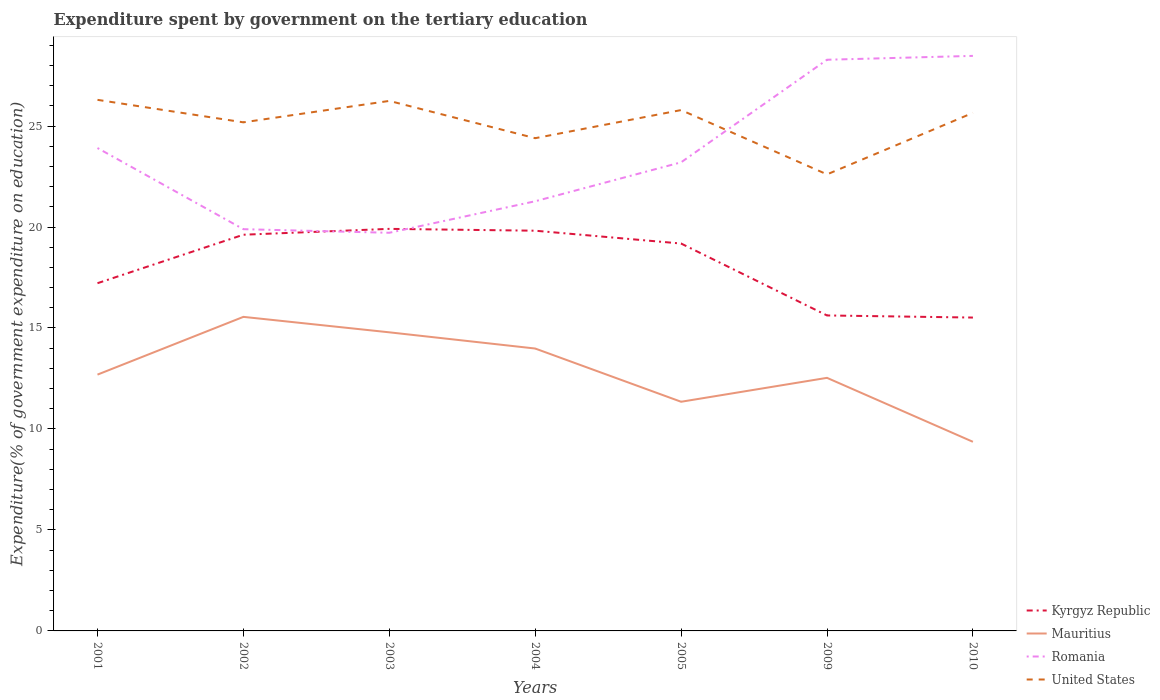Is the number of lines equal to the number of legend labels?
Your response must be concise. Yes. Across all years, what is the maximum expenditure spent by government on the tertiary education in United States?
Your answer should be compact. 22.61. In which year was the expenditure spent by government on the tertiary education in Romania maximum?
Your response must be concise. 2003. What is the total expenditure spent by government on the tertiary education in Kyrgyz Republic in the graph?
Provide a short and direct response. 0.44. What is the difference between the highest and the second highest expenditure spent by government on the tertiary education in Kyrgyz Republic?
Your answer should be compact. 4.39. What is the difference between the highest and the lowest expenditure spent by government on the tertiary education in Mauritius?
Your response must be concise. 3. Is the expenditure spent by government on the tertiary education in Mauritius strictly greater than the expenditure spent by government on the tertiary education in United States over the years?
Provide a short and direct response. Yes. How many lines are there?
Provide a short and direct response. 4. What is the difference between two consecutive major ticks on the Y-axis?
Provide a short and direct response. 5. Does the graph contain any zero values?
Provide a short and direct response. No. Does the graph contain grids?
Your answer should be compact. No. Where does the legend appear in the graph?
Ensure brevity in your answer.  Bottom right. How many legend labels are there?
Make the answer very short. 4. How are the legend labels stacked?
Provide a succinct answer. Vertical. What is the title of the graph?
Ensure brevity in your answer.  Expenditure spent by government on the tertiary education. Does "South Asia" appear as one of the legend labels in the graph?
Give a very brief answer. No. What is the label or title of the Y-axis?
Keep it short and to the point. Expenditure(% of government expenditure on education). What is the Expenditure(% of government expenditure on education) in Kyrgyz Republic in 2001?
Keep it short and to the point. 17.22. What is the Expenditure(% of government expenditure on education) in Mauritius in 2001?
Your answer should be very brief. 12.69. What is the Expenditure(% of government expenditure on education) in Romania in 2001?
Ensure brevity in your answer.  23.91. What is the Expenditure(% of government expenditure on education) in United States in 2001?
Your answer should be compact. 26.3. What is the Expenditure(% of government expenditure on education) of Kyrgyz Republic in 2002?
Offer a very short reply. 19.62. What is the Expenditure(% of government expenditure on education) in Mauritius in 2002?
Your answer should be compact. 15.55. What is the Expenditure(% of government expenditure on education) in Romania in 2002?
Offer a terse response. 19.89. What is the Expenditure(% of government expenditure on education) of United States in 2002?
Offer a very short reply. 25.18. What is the Expenditure(% of government expenditure on education) of Kyrgyz Republic in 2003?
Your answer should be very brief. 19.91. What is the Expenditure(% of government expenditure on education) of Mauritius in 2003?
Provide a succinct answer. 14.79. What is the Expenditure(% of government expenditure on education) of Romania in 2003?
Your response must be concise. 19.71. What is the Expenditure(% of government expenditure on education) of United States in 2003?
Keep it short and to the point. 26.25. What is the Expenditure(% of government expenditure on education) in Kyrgyz Republic in 2004?
Give a very brief answer. 19.82. What is the Expenditure(% of government expenditure on education) of Mauritius in 2004?
Your answer should be very brief. 13.98. What is the Expenditure(% of government expenditure on education) in Romania in 2004?
Provide a short and direct response. 21.28. What is the Expenditure(% of government expenditure on education) of United States in 2004?
Your answer should be compact. 24.4. What is the Expenditure(% of government expenditure on education) of Kyrgyz Republic in 2005?
Provide a short and direct response. 19.18. What is the Expenditure(% of government expenditure on education) in Mauritius in 2005?
Make the answer very short. 11.35. What is the Expenditure(% of government expenditure on education) of Romania in 2005?
Offer a very short reply. 23.2. What is the Expenditure(% of government expenditure on education) in United States in 2005?
Offer a terse response. 25.79. What is the Expenditure(% of government expenditure on education) of Kyrgyz Republic in 2009?
Make the answer very short. 15.62. What is the Expenditure(% of government expenditure on education) of Mauritius in 2009?
Offer a very short reply. 12.53. What is the Expenditure(% of government expenditure on education) in Romania in 2009?
Ensure brevity in your answer.  28.28. What is the Expenditure(% of government expenditure on education) of United States in 2009?
Offer a very short reply. 22.61. What is the Expenditure(% of government expenditure on education) in Kyrgyz Republic in 2010?
Ensure brevity in your answer.  15.52. What is the Expenditure(% of government expenditure on education) in Mauritius in 2010?
Offer a terse response. 9.36. What is the Expenditure(% of government expenditure on education) in Romania in 2010?
Give a very brief answer. 28.47. What is the Expenditure(% of government expenditure on education) of United States in 2010?
Ensure brevity in your answer.  25.65. Across all years, what is the maximum Expenditure(% of government expenditure on education) in Kyrgyz Republic?
Ensure brevity in your answer.  19.91. Across all years, what is the maximum Expenditure(% of government expenditure on education) of Mauritius?
Give a very brief answer. 15.55. Across all years, what is the maximum Expenditure(% of government expenditure on education) in Romania?
Ensure brevity in your answer.  28.47. Across all years, what is the maximum Expenditure(% of government expenditure on education) in United States?
Offer a very short reply. 26.3. Across all years, what is the minimum Expenditure(% of government expenditure on education) in Kyrgyz Republic?
Give a very brief answer. 15.52. Across all years, what is the minimum Expenditure(% of government expenditure on education) in Mauritius?
Your response must be concise. 9.36. Across all years, what is the minimum Expenditure(% of government expenditure on education) of Romania?
Provide a succinct answer. 19.71. Across all years, what is the minimum Expenditure(% of government expenditure on education) of United States?
Keep it short and to the point. 22.61. What is the total Expenditure(% of government expenditure on education) in Kyrgyz Republic in the graph?
Ensure brevity in your answer.  126.88. What is the total Expenditure(% of government expenditure on education) in Mauritius in the graph?
Offer a terse response. 90.26. What is the total Expenditure(% of government expenditure on education) in Romania in the graph?
Offer a terse response. 164.76. What is the total Expenditure(% of government expenditure on education) in United States in the graph?
Provide a short and direct response. 176.18. What is the difference between the Expenditure(% of government expenditure on education) in Kyrgyz Republic in 2001 and that in 2002?
Ensure brevity in your answer.  -2.4. What is the difference between the Expenditure(% of government expenditure on education) of Mauritius in 2001 and that in 2002?
Ensure brevity in your answer.  -2.86. What is the difference between the Expenditure(% of government expenditure on education) of Romania in 2001 and that in 2002?
Keep it short and to the point. 4.02. What is the difference between the Expenditure(% of government expenditure on education) in United States in 2001 and that in 2002?
Make the answer very short. 1.11. What is the difference between the Expenditure(% of government expenditure on education) in Kyrgyz Republic in 2001 and that in 2003?
Give a very brief answer. -2.69. What is the difference between the Expenditure(% of government expenditure on education) of Mauritius in 2001 and that in 2003?
Ensure brevity in your answer.  -2.09. What is the difference between the Expenditure(% of government expenditure on education) of Romania in 2001 and that in 2003?
Keep it short and to the point. 4.2. What is the difference between the Expenditure(% of government expenditure on education) of United States in 2001 and that in 2003?
Provide a short and direct response. 0.05. What is the difference between the Expenditure(% of government expenditure on education) of Kyrgyz Republic in 2001 and that in 2004?
Ensure brevity in your answer.  -2.6. What is the difference between the Expenditure(% of government expenditure on education) of Mauritius in 2001 and that in 2004?
Keep it short and to the point. -1.29. What is the difference between the Expenditure(% of government expenditure on education) in Romania in 2001 and that in 2004?
Your answer should be very brief. 2.64. What is the difference between the Expenditure(% of government expenditure on education) in United States in 2001 and that in 2004?
Offer a very short reply. 1.9. What is the difference between the Expenditure(% of government expenditure on education) in Kyrgyz Republic in 2001 and that in 2005?
Your answer should be compact. -1.96. What is the difference between the Expenditure(% of government expenditure on education) of Mauritius in 2001 and that in 2005?
Give a very brief answer. 1.34. What is the difference between the Expenditure(% of government expenditure on education) in Romania in 2001 and that in 2005?
Provide a short and direct response. 0.71. What is the difference between the Expenditure(% of government expenditure on education) of United States in 2001 and that in 2005?
Your response must be concise. 0.51. What is the difference between the Expenditure(% of government expenditure on education) of Kyrgyz Republic in 2001 and that in 2009?
Give a very brief answer. 1.6. What is the difference between the Expenditure(% of government expenditure on education) of Mauritius in 2001 and that in 2009?
Keep it short and to the point. 0.16. What is the difference between the Expenditure(% of government expenditure on education) in Romania in 2001 and that in 2009?
Give a very brief answer. -4.37. What is the difference between the Expenditure(% of government expenditure on education) of United States in 2001 and that in 2009?
Ensure brevity in your answer.  3.69. What is the difference between the Expenditure(% of government expenditure on education) of Kyrgyz Republic in 2001 and that in 2010?
Give a very brief answer. 1.7. What is the difference between the Expenditure(% of government expenditure on education) in Mauritius in 2001 and that in 2010?
Your response must be concise. 3.33. What is the difference between the Expenditure(% of government expenditure on education) in Romania in 2001 and that in 2010?
Provide a succinct answer. -4.56. What is the difference between the Expenditure(% of government expenditure on education) of United States in 2001 and that in 2010?
Provide a short and direct response. 0.64. What is the difference between the Expenditure(% of government expenditure on education) in Kyrgyz Republic in 2002 and that in 2003?
Your answer should be very brief. -0.29. What is the difference between the Expenditure(% of government expenditure on education) of Mauritius in 2002 and that in 2003?
Offer a very short reply. 0.76. What is the difference between the Expenditure(% of government expenditure on education) in Romania in 2002 and that in 2003?
Keep it short and to the point. 0.18. What is the difference between the Expenditure(% of government expenditure on education) of United States in 2002 and that in 2003?
Keep it short and to the point. -1.06. What is the difference between the Expenditure(% of government expenditure on education) of Kyrgyz Republic in 2002 and that in 2004?
Your answer should be compact. -0.2. What is the difference between the Expenditure(% of government expenditure on education) in Mauritius in 2002 and that in 2004?
Ensure brevity in your answer.  1.57. What is the difference between the Expenditure(% of government expenditure on education) of Romania in 2002 and that in 2004?
Ensure brevity in your answer.  -1.38. What is the difference between the Expenditure(% of government expenditure on education) in United States in 2002 and that in 2004?
Provide a short and direct response. 0.78. What is the difference between the Expenditure(% of government expenditure on education) of Kyrgyz Republic in 2002 and that in 2005?
Your answer should be compact. 0.44. What is the difference between the Expenditure(% of government expenditure on education) of Mauritius in 2002 and that in 2005?
Make the answer very short. 4.2. What is the difference between the Expenditure(% of government expenditure on education) of Romania in 2002 and that in 2005?
Provide a short and direct response. -3.31. What is the difference between the Expenditure(% of government expenditure on education) in United States in 2002 and that in 2005?
Your answer should be compact. -0.61. What is the difference between the Expenditure(% of government expenditure on education) of Kyrgyz Republic in 2002 and that in 2009?
Your answer should be very brief. 4. What is the difference between the Expenditure(% of government expenditure on education) of Mauritius in 2002 and that in 2009?
Provide a short and direct response. 3.02. What is the difference between the Expenditure(% of government expenditure on education) in Romania in 2002 and that in 2009?
Offer a terse response. -8.39. What is the difference between the Expenditure(% of government expenditure on education) of United States in 2002 and that in 2009?
Ensure brevity in your answer.  2.58. What is the difference between the Expenditure(% of government expenditure on education) of Kyrgyz Republic in 2002 and that in 2010?
Your response must be concise. 4.1. What is the difference between the Expenditure(% of government expenditure on education) of Mauritius in 2002 and that in 2010?
Make the answer very short. 6.19. What is the difference between the Expenditure(% of government expenditure on education) of Romania in 2002 and that in 2010?
Your response must be concise. -8.58. What is the difference between the Expenditure(% of government expenditure on education) in United States in 2002 and that in 2010?
Your answer should be compact. -0.47. What is the difference between the Expenditure(% of government expenditure on education) of Kyrgyz Republic in 2003 and that in 2004?
Your answer should be very brief. 0.09. What is the difference between the Expenditure(% of government expenditure on education) of Mauritius in 2003 and that in 2004?
Offer a very short reply. 0.8. What is the difference between the Expenditure(% of government expenditure on education) of Romania in 2003 and that in 2004?
Provide a succinct answer. -1.56. What is the difference between the Expenditure(% of government expenditure on education) in United States in 2003 and that in 2004?
Provide a short and direct response. 1.85. What is the difference between the Expenditure(% of government expenditure on education) in Kyrgyz Republic in 2003 and that in 2005?
Your response must be concise. 0.73. What is the difference between the Expenditure(% of government expenditure on education) in Mauritius in 2003 and that in 2005?
Your answer should be very brief. 3.44. What is the difference between the Expenditure(% of government expenditure on education) of Romania in 2003 and that in 2005?
Make the answer very short. -3.49. What is the difference between the Expenditure(% of government expenditure on education) in United States in 2003 and that in 2005?
Offer a terse response. 0.45. What is the difference between the Expenditure(% of government expenditure on education) in Kyrgyz Republic in 2003 and that in 2009?
Ensure brevity in your answer.  4.29. What is the difference between the Expenditure(% of government expenditure on education) in Mauritius in 2003 and that in 2009?
Provide a succinct answer. 2.25. What is the difference between the Expenditure(% of government expenditure on education) in Romania in 2003 and that in 2009?
Your response must be concise. -8.57. What is the difference between the Expenditure(% of government expenditure on education) of United States in 2003 and that in 2009?
Offer a terse response. 3.64. What is the difference between the Expenditure(% of government expenditure on education) of Kyrgyz Republic in 2003 and that in 2010?
Offer a terse response. 4.39. What is the difference between the Expenditure(% of government expenditure on education) of Mauritius in 2003 and that in 2010?
Ensure brevity in your answer.  5.42. What is the difference between the Expenditure(% of government expenditure on education) in Romania in 2003 and that in 2010?
Your response must be concise. -8.76. What is the difference between the Expenditure(% of government expenditure on education) of United States in 2003 and that in 2010?
Keep it short and to the point. 0.59. What is the difference between the Expenditure(% of government expenditure on education) in Kyrgyz Republic in 2004 and that in 2005?
Provide a succinct answer. 0.64. What is the difference between the Expenditure(% of government expenditure on education) in Mauritius in 2004 and that in 2005?
Offer a very short reply. 2.64. What is the difference between the Expenditure(% of government expenditure on education) of Romania in 2004 and that in 2005?
Ensure brevity in your answer.  -1.93. What is the difference between the Expenditure(% of government expenditure on education) in United States in 2004 and that in 2005?
Keep it short and to the point. -1.39. What is the difference between the Expenditure(% of government expenditure on education) of Kyrgyz Republic in 2004 and that in 2009?
Keep it short and to the point. 4.2. What is the difference between the Expenditure(% of government expenditure on education) of Mauritius in 2004 and that in 2009?
Keep it short and to the point. 1.45. What is the difference between the Expenditure(% of government expenditure on education) of Romania in 2004 and that in 2009?
Offer a very short reply. -7.01. What is the difference between the Expenditure(% of government expenditure on education) of United States in 2004 and that in 2009?
Your response must be concise. 1.79. What is the difference between the Expenditure(% of government expenditure on education) of Kyrgyz Republic in 2004 and that in 2010?
Offer a terse response. 4.3. What is the difference between the Expenditure(% of government expenditure on education) in Mauritius in 2004 and that in 2010?
Give a very brief answer. 4.62. What is the difference between the Expenditure(% of government expenditure on education) in Romania in 2004 and that in 2010?
Offer a terse response. -7.2. What is the difference between the Expenditure(% of government expenditure on education) of United States in 2004 and that in 2010?
Keep it short and to the point. -1.25. What is the difference between the Expenditure(% of government expenditure on education) in Kyrgyz Republic in 2005 and that in 2009?
Offer a very short reply. 3.56. What is the difference between the Expenditure(% of government expenditure on education) of Mauritius in 2005 and that in 2009?
Keep it short and to the point. -1.18. What is the difference between the Expenditure(% of government expenditure on education) of Romania in 2005 and that in 2009?
Provide a succinct answer. -5.08. What is the difference between the Expenditure(% of government expenditure on education) of United States in 2005 and that in 2009?
Ensure brevity in your answer.  3.18. What is the difference between the Expenditure(% of government expenditure on education) in Kyrgyz Republic in 2005 and that in 2010?
Offer a very short reply. 3.67. What is the difference between the Expenditure(% of government expenditure on education) in Mauritius in 2005 and that in 2010?
Provide a succinct answer. 1.98. What is the difference between the Expenditure(% of government expenditure on education) in Romania in 2005 and that in 2010?
Offer a terse response. -5.27. What is the difference between the Expenditure(% of government expenditure on education) of United States in 2005 and that in 2010?
Ensure brevity in your answer.  0.14. What is the difference between the Expenditure(% of government expenditure on education) of Kyrgyz Republic in 2009 and that in 2010?
Make the answer very short. 0.1. What is the difference between the Expenditure(% of government expenditure on education) in Mauritius in 2009 and that in 2010?
Offer a terse response. 3.17. What is the difference between the Expenditure(% of government expenditure on education) of Romania in 2009 and that in 2010?
Offer a very short reply. -0.19. What is the difference between the Expenditure(% of government expenditure on education) of United States in 2009 and that in 2010?
Give a very brief answer. -3.05. What is the difference between the Expenditure(% of government expenditure on education) in Kyrgyz Republic in 2001 and the Expenditure(% of government expenditure on education) in Mauritius in 2002?
Provide a succinct answer. 1.67. What is the difference between the Expenditure(% of government expenditure on education) of Kyrgyz Republic in 2001 and the Expenditure(% of government expenditure on education) of Romania in 2002?
Provide a short and direct response. -2.67. What is the difference between the Expenditure(% of government expenditure on education) of Kyrgyz Republic in 2001 and the Expenditure(% of government expenditure on education) of United States in 2002?
Keep it short and to the point. -7.97. What is the difference between the Expenditure(% of government expenditure on education) in Mauritius in 2001 and the Expenditure(% of government expenditure on education) in Romania in 2002?
Make the answer very short. -7.2. What is the difference between the Expenditure(% of government expenditure on education) in Mauritius in 2001 and the Expenditure(% of government expenditure on education) in United States in 2002?
Offer a very short reply. -12.49. What is the difference between the Expenditure(% of government expenditure on education) of Romania in 2001 and the Expenditure(% of government expenditure on education) of United States in 2002?
Offer a terse response. -1.27. What is the difference between the Expenditure(% of government expenditure on education) in Kyrgyz Republic in 2001 and the Expenditure(% of government expenditure on education) in Mauritius in 2003?
Keep it short and to the point. 2.43. What is the difference between the Expenditure(% of government expenditure on education) in Kyrgyz Republic in 2001 and the Expenditure(% of government expenditure on education) in Romania in 2003?
Give a very brief answer. -2.5. What is the difference between the Expenditure(% of government expenditure on education) in Kyrgyz Republic in 2001 and the Expenditure(% of government expenditure on education) in United States in 2003?
Offer a terse response. -9.03. What is the difference between the Expenditure(% of government expenditure on education) of Mauritius in 2001 and the Expenditure(% of government expenditure on education) of Romania in 2003?
Ensure brevity in your answer.  -7.02. What is the difference between the Expenditure(% of government expenditure on education) in Mauritius in 2001 and the Expenditure(% of government expenditure on education) in United States in 2003?
Your response must be concise. -13.55. What is the difference between the Expenditure(% of government expenditure on education) of Romania in 2001 and the Expenditure(% of government expenditure on education) of United States in 2003?
Offer a terse response. -2.33. What is the difference between the Expenditure(% of government expenditure on education) of Kyrgyz Republic in 2001 and the Expenditure(% of government expenditure on education) of Mauritius in 2004?
Ensure brevity in your answer.  3.23. What is the difference between the Expenditure(% of government expenditure on education) in Kyrgyz Republic in 2001 and the Expenditure(% of government expenditure on education) in Romania in 2004?
Ensure brevity in your answer.  -4.06. What is the difference between the Expenditure(% of government expenditure on education) of Kyrgyz Republic in 2001 and the Expenditure(% of government expenditure on education) of United States in 2004?
Provide a succinct answer. -7.18. What is the difference between the Expenditure(% of government expenditure on education) of Mauritius in 2001 and the Expenditure(% of government expenditure on education) of Romania in 2004?
Offer a very short reply. -8.59. What is the difference between the Expenditure(% of government expenditure on education) of Mauritius in 2001 and the Expenditure(% of government expenditure on education) of United States in 2004?
Provide a short and direct response. -11.71. What is the difference between the Expenditure(% of government expenditure on education) of Romania in 2001 and the Expenditure(% of government expenditure on education) of United States in 2004?
Provide a short and direct response. -0.49. What is the difference between the Expenditure(% of government expenditure on education) of Kyrgyz Republic in 2001 and the Expenditure(% of government expenditure on education) of Mauritius in 2005?
Keep it short and to the point. 5.87. What is the difference between the Expenditure(% of government expenditure on education) of Kyrgyz Republic in 2001 and the Expenditure(% of government expenditure on education) of Romania in 2005?
Ensure brevity in your answer.  -5.99. What is the difference between the Expenditure(% of government expenditure on education) in Kyrgyz Republic in 2001 and the Expenditure(% of government expenditure on education) in United States in 2005?
Keep it short and to the point. -8.57. What is the difference between the Expenditure(% of government expenditure on education) in Mauritius in 2001 and the Expenditure(% of government expenditure on education) in Romania in 2005?
Give a very brief answer. -10.51. What is the difference between the Expenditure(% of government expenditure on education) of Mauritius in 2001 and the Expenditure(% of government expenditure on education) of United States in 2005?
Ensure brevity in your answer.  -13.1. What is the difference between the Expenditure(% of government expenditure on education) of Romania in 2001 and the Expenditure(% of government expenditure on education) of United States in 2005?
Give a very brief answer. -1.88. What is the difference between the Expenditure(% of government expenditure on education) in Kyrgyz Republic in 2001 and the Expenditure(% of government expenditure on education) in Mauritius in 2009?
Ensure brevity in your answer.  4.69. What is the difference between the Expenditure(% of government expenditure on education) of Kyrgyz Republic in 2001 and the Expenditure(% of government expenditure on education) of Romania in 2009?
Offer a terse response. -11.06. What is the difference between the Expenditure(% of government expenditure on education) of Kyrgyz Republic in 2001 and the Expenditure(% of government expenditure on education) of United States in 2009?
Provide a succinct answer. -5.39. What is the difference between the Expenditure(% of government expenditure on education) in Mauritius in 2001 and the Expenditure(% of government expenditure on education) in Romania in 2009?
Give a very brief answer. -15.59. What is the difference between the Expenditure(% of government expenditure on education) of Mauritius in 2001 and the Expenditure(% of government expenditure on education) of United States in 2009?
Your response must be concise. -9.92. What is the difference between the Expenditure(% of government expenditure on education) of Romania in 2001 and the Expenditure(% of government expenditure on education) of United States in 2009?
Provide a succinct answer. 1.31. What is the difference between the Expenditure(% of government expenditure on education) of Kyrgyz Republic in 2001 and the Expenditure(% of government expenditure on education) of Mauritius in 2010?
Your response must be concise. 7.85. What is the difference between the Expenditure(% of government expenditure on education) of Kyrgyz Republic in 2001 and the Expenditure(% of government expenditure on education) of Romania in 2010?
Offer a very short reply. -11.26. What is the difference between the Expenditure(% of government expenditure on education) in Kyrgyz Republic in 2001 and the Expenditure(% of government expenditure on education) in United States in 2010?
Offer a very short reply. -8.43. What is the difference between the Expenditure(% of government expenditure on education) in Mauritius in 2001 and the Expenditure(% of government expenditure on education) in Romania in 2010?
Ensure brevity in your answer.  -15.78. What is the difference between the Expenditure(% of government expenditure on education) in Mauritius in 2001 and the Expenditure(% of government expenditure on education) in United States in 2010?
Your answer should be compact. -12.96. What is the difference between the Expenditure(% of government expenditure on education) in Romania in 2001 and the Expenditure(% of government expenditure on education) in United States in 2010?
Offer a very short reply. -1.74. What is the difference between the Expenditure(% of government expenditure on education) in Kyrgyz Republic in 2002 and the Expenditure(% of government expenditure on education) in Mauritius in 2003?
Your answer should be very brief. 4.83. What is the difference between the Expenditure(% of government expenditure on education) in Kyrgyz Republic in 2002 and the Expenditure(% of government expenditure on education) in Romania in 2003?
Your answer should be very brief. -0.1. What is the difference between the Expenditure(% of government expenditure on education) in Kyrgyz Republic in 2002 and the Expenditure(% of government expenditure on education) in United States in 2003?
Your response must be concise. -6.63. What is the difference between the Expenditure(% of government expenditure on education) in Mauritius in 2002 and the Expenditure(% of government expenditure on education) in Romania in 2003?
Keep it short and to the point. -4.16. What is the difference between the Expenditure(% of government expenditure on education) of Mauritius in 2002 and the Expenditure(% of government expenditure on education) of United States in 2003?
Give a very brief answer. -10.69. What is the difference between the Expenditure(% of government expenditure on education) of Romania in 2002 and the Expenditure(% of government expenditure on education) of United States in 2003?
Give a very brief answer. -6.35. What is the difference between the Expenditure(% of government expenditure on education) of Kyrgyz Republic in 2002 and the Expenditure(% of government expenditure on education) of Mauritius in 2004?
Offer a terse response. 5.64. What is the difference between the Expenditure(% of government expenditure on education) of Kyrgyz Republic in 2002 and the Expenditure(% of government expenditure on education) of Romania in 2004?
Your response must be concise. -1.66. What is the difference between the Expenditure(% of government expenditure on education) of Kyrgyz Republic in 2002 and the Expenditure(% of government expenditure on education) of United States in 2004?
Offer a terse response. -4.78. What is the difference between the Expenditure(% of government expenditure on education) in Mauritius in 2002 and the Expenditure(% of government expenditure on education) in Romania in 2004?
Give a very brief answer. -5.73. What is the difference between the Expenditure(% of government expenditure on education) of Mauritius in 2002 and the Expenditure(% of government expenditure on education) of United States in 2004?
Give a very brief answer. -8.85. What is the difference between the Expenditure(% of government expenditure on education) of Romania in 2002 and the Expenditure(% of government expenditure on education) of United States in 2004?
Offer a very short reply. -4.51. What is the difference between the Expenditure(% of government expenditure on education) of Kyrgyz Republic in 2002 and the Expenditure(% of government expenditure on education) of Mauritius in 2005?
Provide a short and direct response. 8.27. What is the difference between the Expenditure(% of government expenditure on education) of Kyrgyz Republic in 2002 and the Expenditure(% of government expenditure on education) of Romania in 2005?
Keep it short and to the point. -3.59. What is the difference between the Expenditure(% of government expenditure on education) in Kyrgyz Republic in 2002 and the Expenditure(% of government expenditure on education) in United States in 2005?
Provide a succinct answer. -6.17. What is the difference between the Expenditure(% of government expenditure on education) of Mauritius in 2002 and the Expenditure(% of government expenditure on education) of Romania in 2005?
Keep it short and to the point. -7.65. What is the difference between the Expenditure(% of government expenditure on education) of Mauritius in 2002 and the Expenditure(% of government expenditure on education) of United States in 2005?
Offer a terse response. -10.24. What is the difference between the Expenditure(% of government expenditure on education) of Romania in 2002 and the Expenditure(% of government expenditure on education) of United States in 2005?
Provide a short and direct response. -5.9. What is the difference between the Expenditure(% of government expenditure on education) of Kyrgyz Republic in 2002 and the Expenditure(% of government expenditure on education) of Mauritius in 2009?
Ensure brevity in your answer.  7.09. What is the difference between the Expenditure(% of government expenditure on education) of Kyrgyz Republic in 2002 and the Expenditure(% of government expenditure on education) of Romania in 2009?
Provide a short and direct response. -8.66. What is the difference between the Expenditure(% of government expenditure on education) of Kyrgyz Republic in 2002 and the Expenditure(% of government expenditure on education) of United States in 2009?
Keep it short and to the point. -2.99. What is the difference between the Expenditure(% of government expenditure on education) in Mauritius in 2002 and the Expenditure(% of government expenditure on education) in Romania in 2009?
Provide a succinct answer. -12.73. What is the difference between the Expenditure(% of government expenditure on education) of Mauritius in 2002 and the Expenditure(% of government expenditure on education) of United States in 2009?
Your response must be concise. -7.06. What is the difference between the Expenditure(% of government expenditure on education) of Romania in 2002 and the Expenditure(% of government expenditure on education) of United States in 2009?
Offer a terse response. -2.71. What is the difference between the Expenditure(% of government expenditure on education) in Kyrgyz Republic in 2002 and the Expenditure(% of government expenditure on education) in Mauritius in 2010?
Give a very brief answer. 10.25. What is the difference between the Expenditure(% of government expenditure on education) in Kyrgyz Republic in 2002 and the Expenditure(% of government expenditure on education) in Romania in 2010?
Give a very brief answer. -8.86. What is the difference between the Expenditure(% of government expenditure on education) of Kyrgyz Republic in 2002 and the Expenditure(% of government expenditure on education) of United States in 2010?
Provide a short and direct response. -6.03. What is the difference between the Expenditure(% of government expenditure on education) of Mauritius in 2002 and the Expenditure(% of government expenditure on education) of Romania in 2010?
Offer a very short reply. -12.92. What is the difference between the Expenditure(% of government expenditure on education) of Mauritius in 2002 and the Expenditure(% of government expenditure on education) of United States in 2010?
Offer a very short reply. -10.1. What is the difference between the Expenditure(% of government expenditure on education) of Romania in 2002 and the Expenditure(% of government expenditure on education) of United States in 2010?
Provide a succinct answer. -5.76. What is the difference between the Expenditure(% of government expenditure on education) of Kyrgyz Republic in 2003 and the Expenditure(% of government expenditure on education) of Mauritius in 2004?
Your response must be concise. 5.93. What is the difference between the Expenditure(% of government expenditure on education) of Kyrgyz Republic in 2003 and the Expenditure(% of government expenditure on education) of Romania in 2004?
Offer a very short reply. -1.37. What is the difference between the Expenditure(% of government expenditure on education) of Kyrgyz Republic in 2003 and the Expenditure(% of government expenditure on education) of United States in 2004?
Provide a succinct answer. -4.49. What is the difference between the Expenditure(% of government expenditure on education) in Mauritius in 2003 and the Expenditure(% of government expenditure on education) in Romania in 2004?
Ensure brevity in your answer.  -6.49. What is the difference between the Expenditure(% of government expenditure on education) of Mauritius in 2003 and the Expenditure(% of government expenditure on education) of United States in 2004?
Make the answer very short. -9.61. What is the difference between the Expenditure(% of government expenditure on education) in Romania in 2003 and the Expenditure(% of government expenditure on education) in United States in 2004?
Ensure brevity in your answer.  -4.68. What is the difference between the Expenditure(% of government expenditure on education) in Kyrgyz Republic in 2003 and the Expenditure(% of government expenditure on education) in Mauritius in 2005?
Your answer should be compact. 8.56. What is the difference between the Expenditure(% of government expenditure on education) in Kyrgyz Republic in 2003 and the Expenditure(% of government expenditure on education) in Romania in 2005?
Offer a very short reply. -3.3. What is the difference between the Expenditure(% of government expenditure on education) of Kyrgyz Republic in 2003 and the Expenditure(% of government expenditure on education) of United States in 2005?
Provide a short and direct response. -5.88. What is the difference between the Expenditure(% of government expenditure on education) of Mauritius in 2003 and the Expenditure(% of government expenditure on education) of Romania in 2005?
Ensure brevity in your answer.  -8.42. What is the difference between the Expenditure(% of government expenditure on education) in Mauritius in 2003 and the Expenditure(% of government expenditure on education) in United States in 2005?
Make the answer very short. -11.01. What is the difference between the Expenditure(% of government expenditure on education) in Romania in 2003 and the Expenditure(% of government expenditure on education) in United States in 2005?
Keep it short and to the point. -6.08. What is the difference between the Expenditure(% of government expenditure on education) of Kyrgyz Republic in 2003 and the Expenditure(% of government expenditure on education) of Mauritius in 2009?
Keep it short and to the point. 7.38. What is the difference between the Expenditure(% of government expenditure on education) in Kyrgyz Republic in 2003 and the Expenditure(% of government expenditure on education) in Romania in 2009?
Give a very brief answer. -8.37. What is the difference between the Expenditure(% of government expenditure on education) in Kyrgyz Republic in 2003 and the Expenditure(% of government expenditure on education) in United States in 2009?
Ensure brevity in your answer.  -2.7. What is the difference between the Expenditure(% of government expenditure on education) in Mauritius in 2003 and the Expenditure(% of government expenditure on education) in Romania in 2009?
Make the answer very short. -13.5. What is the difference between the Expenditure(% of government expenditure on education) of Mauritius in 2003 and the Expenditure(% of government expenditure on education) of United States in 2009?
Your answer should be compact. -7.82. What is the difference between the Expenditure(% of government expenditure on education) in Romania in 2003 and the Expenditure(% of government expenditure on education) in United States in 2009?
Offer a very short reply. -2.89. What is the difference between the Expenditure(% of government expenditure on education) in Kyrgyz Republic in 2003 and the Expenditure(% of government expenditure on education) in Mauritius in 2010?
Keep it short and to the point. 10.54. What is the difference between the Expenditure(% of government expenditure on education) in Kyrgyz Republic in 2003 and the Expenditure(% of government expenditure on education) in Romania in 2010?
Your response must be concise. -8.57. What is the difference between the Expenditure(% of government expenditure on education) of Kyrgyz Republic in 2003 and the Expenditure(% of government expenditure on education) of United States in 2010?
Keep it short and to the point. -5.74. What is the difference between the Expenditure(% of government expenditure on education) of Mauritius in 2003 and the Expenditure(% of government expenditure on education) of Romania in 2010?
Keep it short and to the point. -13.69. What is the difference between the Expenditure(% of government expenditure on education) of Mauritius in 2003 and the Expenditure(% of government expenditure on education) of United States in 2010?
Provide a short and direct response. -10.87. What is the difference between the Expenditure(% of government expenditure on education) in Romania in 2003 and the Expenditure(% of government expenditure on education) in United States in 2010?
Make the answer very short. -5.94. What is the difference between the Expenditure(% of government expenditure on education) in Kyrgyz Republic in 2004 and the Expenditure(% of government expenditure on education) in Mauritius in 2005?
Provide a short and direct response. 8.47. What is the difference between the Expenditure(% of government expenditure on education) in Kyrgyz Republic in 2004 and the Expenditure(% of government expenditure on education) in Romania in 2005?
Provide a succinct answer. -3.39. What is the difference between the Expenditure(% of government expenditure on education) of Kyrgyz Republic in 2004 and the Expenditure(% of government expenditure on education) of United States in 2005?
Provide a succinct answer. -5.97. What is the difference between the Expenditure(% of government expenditure on education) of Mauritius in 2004 and the Expenditure(% of government expenditure on education) of Romania in 2005?
Your answer should be very brief. -9.22. What is the difference between the Expenditure(% of government expenditure on education) in Mauritius in 2004 and the Expenditure(% of government expenditure on education) in United States in 2005?
Your answer should be very brief. -11.81. What is the difference between the Expenditure(% of government expenditure on education) in Romania in 2004 and the Expenditure(% of government expenditure on education) in United States in 2005?
Give a very brief answer. -4.51. What is the difference between the Expenditure(% of government expenditure on education) of Kyrgyz Republic in 2004 and the Expenditure(% of government expenditure on education) of Mauritius in 2009?
Your answer should be compact. 7.29. What is the difference between the Expenditure(% of government expenditure on education) of Kyrgyz Republic in 2004 and the Expenditure(% of government expenditure on education) of Romania in 2009?
Ensure brevity in your answer.  -8.47. What is the difference between the Expenditure(% of government expenditure on education) of Kyrgyz Republic in 2004 and the Expenditure(% of government expenditure on education) of United States in 2009?
Offer a terse response. -2.79. What is the difference between the Expenditure(% of government expenditure on education) in Mauritius in 2004 and the Expenditure(% of government expenditure on education) in Romania in 2009?
Provide a short and direct response. -14.3. What is the difference between the Expenditure(% of government expenditure on education) in Mauritius in 2004 and the Expenditure(% of government expenditure on education) in United States in 2009?
Keep it short and to the point. -8.62. What is the difference between the Expenditure(% of government expenditure on education) of Romania in 2004 and the Expenditure(% of government expenditure on education) of United States in 2009?
Your answer should be compact. -1.33. What is the difference between the Expenditure(% of government expenditure on education) in Kyrgyz Republic in 2004 and the Expenditure(% of government expenditure on education) in Mauritius in 2010?
Ensure brevity in your answer.  10.45. What is the difference between the Expenditure(% of government expenditure on education) in Kyrgyz Republic in 2004 and the Expenditure(% of government expenditure on education) in Romania in 2010?
Offer a terse response. -8.66. What is the difference between the Expenditure(% of government expenditure on education) in Kyrgyz Republic in 2004 and the Expenditure(% of government expenditure on education) in United States in 2010?
Your answer should be compact. -5.84. What is the difference between the Expenditure(% of government expenditure on education) in Mauritius in 2004 and the Expenditure(% of government expenditure on education) in Romania in 2010?
Provide a short and direct response. -14.49. What is the difference between the Expenditure(% of government expenditure on education) of Mauritius in 2004 and the Expenditure(% of government expenditure on education) of United States in 2010?
Your response must be concise. -11.67. What is the difference between the Expenditure(% of government expenditure on education) of Romania in 2004 and the Expenditure(% of government expenditure on education) of United States in 2010?
Provide a short and direct response. -4.38. What is the difference between the Expenditure(% of government expenditure on education) of Kyrgyz Republic in 2005 and the Expenditure(% of government expenditure on education) of Mauritius in 2009?
Give a very brief answer. 6.65. What is the difference between the Expenditure(% of government expenditure on education) in Kyrgyz Republic in 2005 and the Expenditure(% of government expenditure on education) in Romania in 2009?
Your response must be concise. -9.1. What is the difference between the Expenditure(% of government expenditure on education) in Kyrgyz Republic in 2005 and the Expenditure(% of government expenditure on education) in United States in 2009?
Your answer should be compact. -3.42. What is the difference between the Expenditure(% of government expenditure on education) in Mauritius in 2005 and the Expenditure(% of government expenditure on education) in Romania in 2009?
Offer a terse response. -16.94. What is the difference between the Expenditure(% of government expenditure on education) in Mauritius in 2005 and the Expenditure(% of government expenditure on education) in United States in 2009?
Keep it short and to the point. -11.26. What is the difference between the Expenditure(% of government expenditure on education) in Romania in 2005 and the Expenditure(% of government expenditure on education) in United States in 2009?
Make the answer very short. 0.6. What is the difference between the Expenditure(% of government expenditure on education) in Kyrgyz Republic in 2005 and the Expenditure(% of government expenditure on education) in Mauritius in 2010?
Provide a short and direct response. 9.82. What is the difference between the Expenditure(% of government expenditure on education) of Kyrgyz Republic in 2005 and the Expenditure(% of government expenditure on education) of Romania in 2010?
Offer a very short reply. -9.29. What is the difference between the Expenditure(% of government expenditure on education) of Kyrgyz Republic in 2005 and the Expenditure(% of government expenditure on education) of United States in 2010?
Your answer should be very brief. -6.47. What is the difference between the Expenditure(% of government expenditure on education) of Mauritius in 2005 and the Expenditure(% of government expenditure on education) of Romania in 2010?
Offer a terse response. -17.13. What is the difference between the Expenditure(% of government expenditure on education) in Mauritius in 2005 and the Expenditure(% of government expenditure on education) in United States in 2010?
Keep it short and to the point. -14.31. What is the difference between the Expenditure(% of government expenditure on education) in Romania in 2005 and the Expenditure(% of government expenditure on education) in United States in 2010?
Provide a short and direct response. -2.45. What is the difference between the Expenditure(% of government expenditure on education) of Kyrgyz Republic in 2009 and the Expenditure(% of government expenditure on education) of Mauritius in 2010?
Offer a terse response. 6.26. What is the difference between the Expenditure(% of government expenditure on education) of Kyrgyz Republic in 2009 and the Expenditure(% of government expenditure on education) of Romania in 2010?
Offer a terse response. -12.85. What is the difference between the Expenditure(% of government expenditure on education) in Kyrgyz Republic in 2009 and the Expenditure(% of government expenditure on education) in United States in 2010?
Ensure brevity in your answer.  -10.03. What is the difference between the Expenditure(% of government expenditure on education) in Mauritius in 2009 and the Expenditure(% of government expenditure on education) in Romania in 2010?
Ensure brevity in your answer.  -15.94. What is the difference between the Expenditure(% of government expenditure on education) in Mauritius in 2009 and the Expenditure(% of government expenditure on education) in United States in 2010?
Your response must be concise. -13.12. What is the difference between the Expenditure(% of government expenditure on education) of Romania in 2009 and the Expenditure(% of government expenditure on education) of United States in 2010?
Ensure brevity in your answer.  2.63. What is the average Expenditure(% of government expenditure on education) in Kyrgyz Republic per year?
Offer a very short reply. 18.13. What is the average Expenditure(% of government expenditure on education) of Mauritius per year?
Give a very brief answer. 12.89. What is the average Expenditure(% of government expenditure on education) of Romania per year?
Offer a very short reply. 23.54. What is the average Expenditure(% of government expenditure on education) in United States per year?
Ensure brevity in your answer.  25.17. In the year 2001, what is the difference between the Expenditure(% of government expenditure on education) in Kyrgyz Republic and Expenditure(% of government expenditure on education) in Mauritius?
Offer a terse response. 4.53. In the year 2001, what is the difference between the Expenditure(% of government expenditure on education) in Kyrgyz Republic and Expenditure(% of government expenditure on education) in Romania?
Offer a very short reply. -6.69. In the year 2001, what is the difference between the Expenditure(% of government expenditure on education) of Kyrgyz Republic and Expenditure(% of government expenditure on education) of United States?
Give a very brief answer. -9.08. In the year 2001, what is the difference between the Expenditure(% of government expenditure on education) of Mauritius and Expenditure(% of government expenditure on education) of Romania?
Offer a terse response. -11.22. In the year 2001, what is the difference between the Expenditure(% of government expenditure on education) in Mauritius and Expenditure(% of government expenditure on education) in United States?
Your answer should be compact. -13.61. In the year 2001, what is the difference between the Expenditure(% of government expenditure on education) of Romania and Expenditure(% of government expenditure on education) of United States?
Give a very brief answer. -2.39. In the year 2002, what is the difference between the Expenditure(% of government expenditure on education) of Kyrgyz Republic and Expenditure(% of government expenditure on education) of Mauritius?
Keep it short and to the point. 4.07. In the year 2002, what is the difference between the Expenditure(% of government expenditure on education) in Kyrgyz Republic and Expenditure(% of government expenditure on education) in Romania?
Your answer should be very brief. -0.27. In the year 2002, what is the difference between the Expenditure(% of government expenditure on education) of Kyrgyz Republic and Expenditure(% of government expenditure on education) of United States?
Provide a short and direct response. -5.57. In the year 2002, what is the difference between the Expenditure(% of government expenditure on education) in Mauritius and Expenditure(% of government expenditure on education) in Romania?
Provide a short and direct response. -4.34. In the year 2002, what is the difference between the Expenditure(% of government expenditure on education) of Mauritius and Expenditure(% of government expenditure on education) of United States?
Offer a very short reply. -9.63. In the year 2002, what is the difference between the Expenditure(% of government expenditure on education) of Romania and Expenditure(% of government expenditure on education) of United States?
Make the answer very short. -5.29. In the year 2003, what is the difference between the Expenditure(% of government expenditure on education) of Kyrgyz Republic and Expenditure(% of government expenditure on education) of Mauritius?
Offer a terse response. 5.12. In the year 2003, what is the difference between the Expenditure(% of government expenditure on education) of Kyrgyz Republic and Expenditure(% of government expenditure on education) of Romania?
Offer a very short reply. 0.19. In the year 2003, what is the difference between the Expenditure(% of government expenditure on education) of Kyrgyz Republic and Expenditure(% of government expenditure on education) of United States?
Your response must be concise. -6.34. In the year 2003, what is the difference between the Expenditure(% of government expenditure on education) of Mauritius and Expenditure(% of government expenditure on education) of Romania?
Your answer should be compact. -4.93. In the year 2003, what is the difference between the Expenditure(% of government expenditure on education) in Mauritius and Expenditure(% of government expenditure on education) in United States?
Provide a succinct answer. -11.46. In the year 2003, what is the difference between the Expenditure(% of government expenditure on education) of Romania and Expenditure(% of government expenditure on education) of United States?
Your answer should be compact. -6.53. In the year 2004, what is the difference between the Expenditure(% of government expenditure on education) of Kyrgyz Republic and Expenditure(% of government expenditure on education) of Mauritius?
Offer a terse response. 5.83. In the year 2004, what is the difference between the Expenditure(% of government expenditure on education) of Kyrgyz Republic and Expenditure(% of government expenditure on education) of Romania?
Your answer should be very brief. -1.46. In the year 2004, what is the difference between the Expenditure(% of government expenditure on education) of Kyrgyz Republic and Expenditure(% of government expenditure on education) of United States?
Provide a short and direct response. -4.58. In the year 2004, what is the difference between the Expenditure(% of government expenditure on education) in Mauritius and Expenditure(% of government expenditure on education) in Romania?
Make the answer very short. -7.29. In the year 2004, what is the difference between the Expenditure(% of government expenditure on education) of Mauritius and Expenditure(% of government expenditure on education) of United States?
Provide a succinct answer. -10.42. In the year 2004, what is the difference between the Expenditure(% of government expenditure on education) of Romania and Expenditure(% of government expenditure on education) of United States?
Your answer should be very brief. -3.12. In the year 2005, what is the difference between the Expenditure(% of government expenditure on education) in Kyrgyz Republic and Expenditure(% of government expenditure on education) in Mauritius?
Provide a succinct answer. 7.83. In the year 2005, what is the difference between the Expenditure(% of government expenditure on education) in Kyrgyz Republic and Expenditure(% of government expenditure on education) in Romania?
Your answer should be very brief. -4.02. In the year 2005, what is the difference between the Expenditure(% of government expenditure on education) of Kyrgyz Republic and Expenditure(% of government expenditure on education) of United States?
Offer a terse response. -6.61. In the year 2005, what is the difference between the Expenditure(% of government expenditure on education) in Mauritius and Expenditure(% of government expenditure on education) in Romania?
Make the answer very short. -11.86. In the year 2005, what is the difference between the Expenditure(% of government expenditure on education) of Mauritius and Expenditure(% of government expenditure on education) of United States?
Keep it short and to the point. -14.44. In the year 2005, what is the difference between the Expenditure(% of government expenditure on education) of Romania and Expenditure(% of government expenditure on education) of United States?
Offer a terse response. -2.59. In the year 2009, what is the difference between the Expenditure(% of government expenditure on education) of Kyrgyz Republic and Expenditure(% of government expenditure on education) of Mauritius?
Provide a succinct answer. 3.09. In the year 2009, what is the difference between the Expenditure(% of government expenditure on education) of Kyrgyz Republic and Expenditure(% of government expenditure on education) of Romania?
Your answer should be very brief. -12.66. In the year 2009, what is the difference between the Expenditure(% of government expenditure on education) in Kyrgyz Republic and Expenditure(% of government expenditure on education) in United States?
Provide a short and direct response. -6.99. In the year 2009, what is the difference between the Expenditure(% of government expenditure on education) in Mauritius and Expenditure(% of government expenditure on education) in Romania?
Make the answer very short. -15.75. In the year 2009, what is the difference between the Expenditure(% of government expenditure on education) of Mauritius and Expenditure(% of government expenditure on education) of United States?
Your answer should be very brief. -10.07. In the year 2009, what is the difference between the Expenditure(% of government expenditure on education) of Romania and Expenditure(% of government expenditure on education) of United States?
Your response must be concise. 5.68. In the year 2010, what is the difference between the Expenditure(% of government expenditure on education) in Kyrgyz Republic and Expenditure(% of government expenditure on education) in Mauritius?
Offer a very short reply. 6.15. In the year 2010, what is the difference between the Expenditure(% of government expenditure on education) in Kyrgyz Republic and Expenditure(% of government expenditure on education) in Romania?
Make the answer very short. -12.96. In the year 2010, what is the difference between the Expenditure(% of government expenditure on education) in Kyrgyz Republic and Expenditure(% of government expenditure on education) in United States?
Your answer should be compact. -10.14. In the year 2010, what is the difference between the Expenditure(% of government expenditure on education) in Mauritius and Expenditure(% of government expenditure on education) in Romania?
Provide a succinct answer. -19.11. In the year 2010, what is the difference between the Expenditure(% of government expenditure on education) of Mauritius and Expenditure(% of government expenditure on education) of United States?
Provide a short and direct response. -16.29. In the year 2010, what is the difference between the Expenditure(% of government expenditure on education) in Romania and Expenditure(% of government expenditure on education) in United States?
Keep it short and to the point. 2.82. What is the ratio of the Expenditure(% of government expenditure on education) in Kyrgyz Republic in 2001 to that in 2002?
Provide a short and direct response. 0.88. What is the ratio of the Expenditure(% of government expenditure on education) of Mauritius in 2001 to that in 2002?
Your answer should be very brief. 0.82. What is the ratio of the Expenditure(% of government expenditure on education) in Romania in 2001 to that in 2002?
Give a very brief answer. 1.2. What is the ratio of the Expenditure(% of government expenditure on education) of United States in 2001 to that in 2002?
Offer a terse response. 1.04. What is the ratio of the Expenditure(% of government expenditure on education) of Kyrgyz Republic in 2001 to that in 2003?
Your answer should be very brief. 0.86. What is the ratio of the Expenditure(% of government expenditure on education) of Mauritius in 2001 to that in 2003?
Offer a very short reply. 0.86. What is the ratio of the Expenditure(% of government expenditure on education) of Romania in 2001 to that in 2003?
Provide a short and direct response. 1.21. What is the ratio of the Expenditure(% of government expenditure on education) in Kyrgyz Republic in 2001 to that in 2004?
Provide a succinct answer. 0.87. What is the ratio of the Expenditure(% of government expenditure on education) of Mauritius in 2001 to that in 2004?
Make the answer very short. 0.91. What is the ratio of the Expenditure(% of government expenditure on education) of Romania in 2001 to that in 2004?
Ensure brevity in your answer.  1.12. What is the ratio of the Expenditure(% of government expenditure on education) in United States in 2001 to that in 2004?
Ensure brevity in your answer.  1.08. What is the ratio of the Expenditure(% of government expenditure on education) of Kyrgyz Republic in 2001 to that in 2005?
Provide a succinct answer. 0.9. What is the ratio of the Expenditure(% of government expenditure on education) in Mauritius in 2001 to that in 2005?
Give a very brief answer. 1.12. What is the ratio of the Expenditure(% of government expenditure on education) in Romania in 2001 to that in 2005?
Ensure brevity in your answer.  1.03. What is the ratio of the Expenditure(% of government expenditure on education) of United States in 2001 to that in 2005?
Your answer should be very brief. 1.02. What is the ratio of the Expenditure(% of government expenditure on education) in Kyrgyz Republic in 2001 to that in 2009?
Your response must be concise. 1.1. What is the ratio of the Expenditure(% of government expenditure on education) in Mauritius in 2001 to that in 2009?
Offer a very short reply. 1.01. What is the ratio of the Expenditure(% of government expenditure on education) of Romania in 2001 to that in 2009?
Offer a terse response. 0.85. What is the ratio of the Expenditure(% of government expenditure on education) of United States in 2001 to that in 2009?
Provide a succinct answer. 1.16. What is the ratio of the Expenditure(% of government expenditure on education) in Kyrgyz Republic in 2001 to that in 2010?
Give a very brief answer. 1.11. What is the ratio of the Expenditure(% of government expenditure on education) of Mauritius in 2001 to that in 2010?
Your response must be concise. 1.36. What is the ratio of the Expenditure(% of government expenditure on education) in Romania in 2001 to that in 2010?
Your answer should be very brief. 0.84. What is the ratio of the Expenditure(% of government expenditure on education) in United States in 2001 to that in 2010?
Provide a short and direct response. 1.03. What is the ratio of the Expenditure(% of government expenditure on education) of Kyrgyz Republic in 2002 to that in 2003?
Offer a very short reply. 0.99. What is the ratio of the Expenditure(% of government expenditure on education) of Mauritius in 2002 to that in 2003?
Your response must be concise. 1.05. What is the ratio of the Expenditure(% of government expenditure on education) of Romania in 2002 to that in 2003?
Provide a short and direct response. 1.01. What is the ratio of the Expenditure(% of government expenditure on education) of United States in 2002 to that in 2003?
Offer a very short reply. 0.96. What is the ratio of the Expenditure(% of government expenditure on education) in Mauritius in 2002 to that in 2004?
Offer a very short reply. 1.11. What is the ratio of the Expenditure(% of government expenditure on education) of Romania in 2002 to that in 2004?
Provide a short and direct response. 0.94. What is the ratio of the Expenditure(% of government expenditure on education) of United States in 2002 to that in 2004?
Give a very brief answer. 1.03. What is the ratio of the Expenditure(% of government expenditure on education) in Kyrgyz Republic in 2002 to that in 2005?
Keep it short and to the point. 1.02. What is the ratio of the Expenditure(% of government expenditure on education) of Mauritius in 2002 to that in 2005?
Ensure brevity in your answer.  1.37. What is the ratio of the Expenditure(% of government expenditure on education) in Romania in 2002 to that in 2005?
Keep it short and to the point. 0.86. What is the ratio of the Expenditure(% of government expenditure on education) of United States in 2002 to that in 2005?
Keep it short and to the point. 0.98. What is the ratio of the Expenditure(% of government expenditure on education) of Kyrgyz Republic in 2002 to that in 2009?
Ensure brevity in your answer.  1.26. What is the ratio of the Expenditure(% of government expenditure on education) of Mauritius in 2002 to that in 2009?
Give a very brief answer. 1.24. What is the ratio of the Expenditure(% of government expenditure on education) of Romania in 2002 to that in 2009?
Your answer should be compact. 0.7. What is the ratio of the Expenditure(% of government expenditure on education) in United States in 2002 to that in 2009?
Offer a terse response. 1.11. What is the ratio of the Expenditure(% of government expenditure on education) of Kyrgyz Republic in 2002 to that in 2010?
Ensure brevity in your answer.  1.26. What is the ratio of the Expenditure(% of government expenditure on education) in Mauritius in 2002 to that in 2010?
Offer a terse response. 1.66. What is the ratio of the Expenditure(% of government expenditure on education) of Romania in 2002 to that in 2010?
Offer a terse response. 0.7. What is the ratio of the Expenditure(% of government expenditure on education) of United States in 2002 to that in 2010?
Keep it short and to the point. 0.98. What is the ratio of the Expenditure(% of government expenditure on education) in Kyrgyz Republic in 2003 to that in 2004?
Keep it short and to the point. 1. What is the ratio of the Expenditure(% of government expenditure on education) of Mauritius in 2003 to that in 2004?
Your answer should be compact. 1.06. What is the ratio of the Expenditure(% of government expenditure on education) of Romania in 2003 to that in 2004?
Ensure brevity in your answer.  0.93. What is the ratio of the Expenditure(% of government expenditure on education) in United States in 2003 to that in 2004?
Offer a very short reply. 1.08. What is the ratio of the Expenditure(% of government expenditure on education) of Kyrgyz Republic in 2003 to that in 2005?
Provide a short and direct response. 1.04. What is the ratio of the Expenditure(% of government expenditure on education) in Mauritius in 2003 to that in 2005?
Give a very brief answer. 1.3. What is the ratio of the Expenditure(% of government expenditure on education) of Romania in 2003 to that in 2005?
Ensure brevity in your answer.  0.85. What is the ratio of the Expenditure(% of government expenditure on education) of United States in 2003 to that in 2005?
Ensure brevity in your answer.  1.02. What is the ratio of the Expenditure(% of government expenditure on education) of Kyrgyz Republic in 2003 to that in 2009?
Your answer should be very brief. 1.27. What is the ratio of the Expenditure(% of government expenditure on education) in Mauritius in 2003 to that in 2009?
Your answer should be very brief. 1.18. What is the ratio of the Expenditure(% of government expenditure on education) in Romania in 2003 to that in 2009?
Keep it short and to the point. 0.7. What is the ratio of the Expenditure(% of government expenditure on education) of United States in 2003 to that in 2009?
Your answer should be very brief. 1.16. What is the ratio of the Expenditure(% of government expenditure on education) in Kyrgyz Republic in 2003 to that in 2010?
Offer a terse response. 1.28. What is the ratio of the Expenditure(% of government expenditure on education) in Mauritius in 2003 to that in 2010?
Offer a terse response. 1.58. What is the ratio of the Expenditure(% of government expenditure on education) in Romania in 2003 to that in 2010?
Offer a very short reply. 0.69. What is the ratio of the Expenditure(% of government expenditure on education) of United States in 2003 to that in 2010?
Give a very brief answer. 1.02. What is the ratio of the Expenditure(% of government expenditure on education) in Kyrgyz Republic in 2004 to that in 2005?
Keep it short and to the point. 1.03. What is the ratio of the Expenditure(% of government expenditure on education) of Mauritius in 2004 to that in 2005?
Ensure brevity in your answer.  1.23. What is the ratio of the Expenditure(% of government expenditure on education) of Romania in 2004 to that in 2005?
Keep it short and to the point. 0.92. What is the ratio of the Expenditure(% of government expenditure on education) in United States in 2004 to that in 2005?
Offer a very short reply. 0.95. What is the ratio of the Expenditure(% of government expenditure on education) of Kyrgyz Republic in 2004 to that in 2009?
Your response must be concise. 1.27. What is the ratio of the Expenditure(% of government expenditure on education) in Mauritius in 2004 to that in 2009?
Make the answer very short. 1.12. What is the ratio of the Expenditure(% of government expenditure on education) in Romania in 2004 to that in 2009?
Make the answer very short. 0.75. What is the ratio of the Expenditure(% of government expenditure on education) of United States in 2004 to that in 2009?
Ensure brevity in your answer.  1.08. What is the ratio of the Expenditure(% of government expenditure on education) in Kyrgyz Republic in 2004 to that in 2010?
Keep it short and to the point. 1.28. What is the ratio of the Expenditure(% of government expenditure on education) in Mauritius in 2004 to that in 2010?
Your response must be concise. 1.49. What is the ratio of the Expenditure(% of government expenditure on education) in Romania in 2004 to that in 2010?
Ensure brevity in your answer.  0.75. What is the ratio of the Expenditure(% of government expenditure on education) of United States in 2004 to that in 2010?
Your answer should be very brief. 0.95. What is the ratio of the Expenditure(% of government expenditure on education) of Kyrgyz Republic in 2005 to that in 2009?
Provide a short and direct response. 1.23. What is the ratio of the Expenditure(% of government expenditure on education) of Mauritius in 2005 to that in 2009?
Give a very brief answer. 0.91. What is the ratio of the Expenditure(% of government expenditure on education) of Romania in 2005 to that in 2009?
Offer a very short reply. 0.82. What is the ratio of the Expenditure(% of government expenditure on education) in United States in 2005 to that in 2009?
Give a very brief answer. 1.14. What is the ratio of the Expenditure(% of government expenditure on education) of Kyrgyz Republic in 2005 to that in 2010?
Offer a terse response. 1.24. What is the ratio of the Expenditure(% of government expenditure on education) in Mauritius in 2005 to that in 2010?
Ensure brevity in your answer.  1.21. What is the ratio of the Expenditure(% of government expenditure on education) in Romania in 2005 to that in 2010?
Make the answer very short. 0.81. What is the ratio of the Expenditure(% of government expenditure on education) of United States in 2005 to that in 2010?
Keep it short and to the point. 1.01. What is the ratio of the Expenditure(% of government expenditure on education) of Mauritius in 2009 to that in 2010?
Make the answer very short. 1.34. What is the ratio of the Expenditure(% of government expenditure on education) of United States in 2009 to that in 2010?
Your answer should be compact. 0.88. What is the difference between the highest and the second highest Expenditure(% of government expenditure on education) in Kyrgyz Republic?
Provide a succinct answer. 0.09. What is the difference between the highest and the second highest Expenditure(% of government expenditure on education) of Mauritius?
Make the answer very short. 0.76. What is the difference between the highest and the second highest Expenditure(% of government expenditure on education) of Romania?
Your answer should be very brief. 0.19. What is the difference between the highest and the second highest Expenditure(% of government expenditure on education) of United States?
Give a very brief answer. 0.05. What is the difference between the highest and the lowest Expenditure(% of government expenditure on education) in Kyrgyz Republic?
Your answer should be very brief. 4.39. What is the difference between the highest and the lowest Expenditure(% of government expenditure on education) in Mauritius?
Offer a terse response. 6.19. What is the difference between the highest and the lowest Expenditure(% of government expenditure on education) in Romania?
Your answer should be compact. 8.76. What is the difference between the highest and the lowest Expenditure(% of government expenditure on education) in United States?
Make the answer very short. 3.69. 